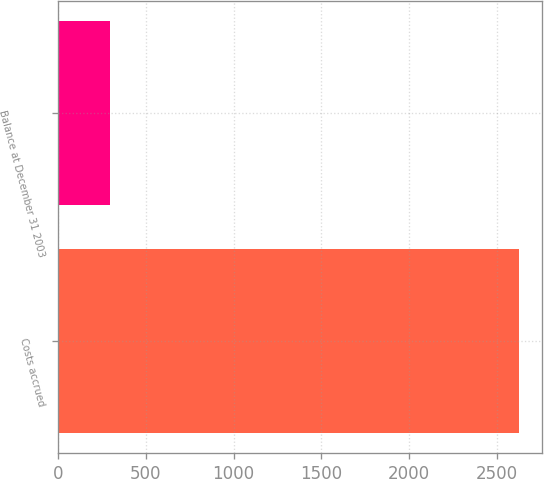Convert chart. <chart><loc_0><loc_0><loc_500><loc_500><bar_chart><fcel>Costs accrued<fcel>Balance at December 31 2003<nl><fcel>2628<fcel>295<nl></chart> 